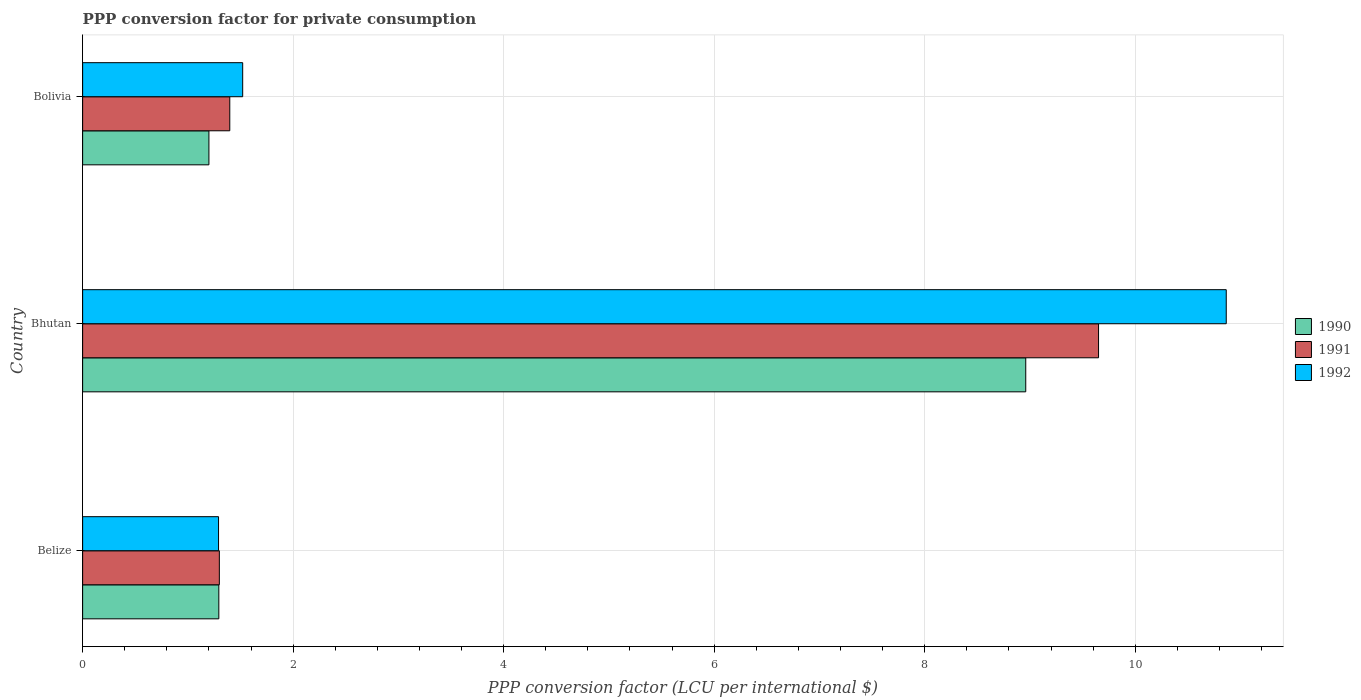How many groups of bars are there?
Your answer should be very brief. 3. Are the number of bars per tick equal to the number of legend labels?
Keep it short and to the point. Yes. What is the label of the 2nd group of bars from the top?
Ensure brevity in your answer.  Bhutan. What is the PPP conversion factor for private consumption in 1992 in Bolivia?
Your answer should be compact. 1.52. Across all countries, what is the maximum PPP conversion factor for private consumption in 1992?
Your answer should be compact. 10.86. Across all countries, what is the minimum PPP conversion factor for private consumption in 1992?
Your answer should be very brief. 1.29. In which country was the PPP conversion factor for private consumption in 1992 maximum?
Your answer should be compact. Bhutan. What is the total PPP conversion factor for private consumption in 1992 in the graph?
Give a very brief answer. 13.68. What is the difference between the PPP conversion factor for private consumption in 1991 in Bhutan and that in Bolivia?
Provide a succinct answer. 8.25. What is the difference between the PPP conversion factor for private consumption in 1992 in Bolivia and the PPP conversion factor for private consumption in 1990 in Belize?
Provide a short and direct response. 0.23. What is the average PPP conversion factor for private consumption in 1990 per country?
Give a very brief answer. 3.82. What is the difference between the PPP conversion factor for private consumption in 1992 and PPP conversion factor for private consumption in 1991 in Bhutan?
Ensure brevity in your answer.  1.21. What is the ratio of the PPP conversion factor for private consumption in 1990 in Bhutan to that in Bolivia?
Offer a very short reply. 7.47. Is the difference between the PPP conversion factor for private consumption in 1992 in Belize and Bhutan greater than the difference between the PPP conversion factor for private consumption in 1991 in Belize and Bhutan?
Make the answer very short. No. What is the difference between the highest and the second highest PPP conversion factor for private consumption in 1990?
Keep it short and to the point. 7.67. What is the difference between the highest and the lowest PPP conversion factor for private consumption in 1992?
Your answer should be compact. 9.57. What does the 2nd bar from the bottom in Bolivia represents?
Your response must be concise. 1991. Are all the bars in the graph horizontal?
Provide a short and direct response. Yes. How many countries are there in the graph?
Keep it short and to the point. 3. Does the graph contain grids?
Offer a very short reply. Yes. Where does the legend appear in the graph?
Provide a succinct answer. Center right. How are the legend labels stacked?
Provide a succinct answer. Vertical. What is the title of the graph?
Your response must be concise. PPP conversion factor for private consumption. Does "1978" appear as one of the legend labels in the graph?
Your answer should be very brief. No. What is the label or title of the X-axis?
Provide a short and direct response. PPP conversion factor (LCU per international $). What is the label or title of the Y-axis?
Your answer should be very brief. Country. What is the PPP conversion factor (LCU per international $) in 1990 in Belize?
Give a very brief answer. 1.29. What is the PPP conversion factor (LCU per international $) in 1991 in Belize?
Your answer should be compact. 1.3. What is the PPP conversion factor (LCU per international $) of 1992 in Belize?
Offer a very short reply. 1.29. What is the PPP conversion factor (LCU per international $) in 1990 in Bhutan?
Ensure brevity in your answer.  8.96. What is the PPP conversion factor (LCU per international $) of 1991 in Bhutan?
Offer a very short reply. 9.65. What is the PPP conversion factor (LCU per international $) of 1992 in Bhutan?
Ensure brevity in your answer.  10.86. What is the PPP conversion factor (LCU per international $) of 1990 in Bolivia?
Your answer should be very brief. 1.2. What is the PPP conversion factor (LCU per international $) in 1991 in Bolivia?
Offer a very short reply. 1.4. What is the PPP conversion factor (LCU per international $) in 1992 in Bolivia?
Your response must be concise. 1.52. Across all countries, what is the maximum PPP conversion factor (LCU per international $) of 1990?
Provide a succinct answer. 8.96. Across all countries, what is the maximum PPP conversion factor (LCU per international $) of 1991?
Provide a succinct answer. 9.65. Across all countries, what is the maximum PPP conversion factor (LCU per international $) in 1992?
Give a very brief answer. 10.86. Across all countries, what is the minimum PPP conversion factor (LCU per international $) in 1990?
Provide a short and direct response. 1.2. Across all countries, what is the minimum PPP conversion factor (LCU per international $) of 1991?
Ensure brevity in your answer.  1.3. Across all countries, what is the minimum PPP conversion factor (LCU per international $) in 1992?
Give a very brief answer. 1.29. What is the total PPP conversion factor (LCU per international $) of 1990 in the graph?
Make the answer very short. 11.45. What is the total PPP conversion factor (LCU per international $) in 1991 in the graph?
Your answer should be very brief. 12.35. What is the total PPP conversion factor (LCU per international $) in 1992 in the graph?
Your answer should be very brief. 13.68. What is the difference between the PPP conversion factor (LCU per international $) of 1990 in Belize and that in Bhutan?
Ensure brevity in your answer.  -7.67. What is the difference between the PPP conversion factor (LCU per international $) of 1991 in Belize and that in Bhutan?
Your response must be concise. -8.35. What is the difference between the PPP conversion factor (LCU per international $) of 1992 in Belize and that in Bhutan?
Offer a terse response. -9.57. What is the difference between the PPP conversion factor (LCU per international $) in 1990 in Belize and that in Bolivia?
Your answer should be very brief. 0.09. What is the difference between the PPP conversion factor (LCU per international $) of 1991 in Belize and that in Bolivia?
Make the answer very short. -0.1. What is the difference between the PPP conversion factor (LCU per international $) in 1992 in Belize and that in Bolivia?
Make the answer very short. -0.23. What is the difference between the PPP conversion factor (LCU per international $) of 1990 in Bhutan and that in Bolivia?
Give a very brief answer. 7.76. What is the difference between the PPP conversion factor (LCU per international $) in 1991 in Bhutan and that in Bolivia?
Ensure brevity in your answer.  8.25. What is the difference between the PPP conversion factor (LCU per international $) in 1992 in Bhutan and that in Bolivia?
Make the answer very short. 9.34. What is the difference between the PPP conversion factor (LCU per international $) of 1990 in Belize and the PPP conversion factor (LCU per international $) of 1991 in Bhutan?
Ensure brevity in your answer.  -8.36. What is the difference between the PPP conversion factor (LCU per international $) in 1990 in Belize and the PPP conversion factor (LCU per international $) in 1992 in Bhutan?
Offer a very short reply. -9.57. What is the difference between the PPP conversion factor (LCU per international $) of 1991 in Belize and the PPP conversion factor (LCU per international $) of 1992 in Bhutan?
Ensure brevity in your answer.  -9.57. What is the difference between the PPP conversion factor (LCU per international $) in 1990 in Belize and the PPP conversion factor (LCU per international $) in 1991 in Bolivia?
Your answer should be very brief. -0.1. What is the difference between the PPP conversion factor (LCU per international $) in 1990 in Belize and the PPP conversion factor (LCU per international $) in 1992 in Bolivia?
Keep it short and to the point. -0.23. What is the difference between the PPP conversion factor (LCU per international $) in 1991 in Belize and the PPP conversion factor (LCU per international $) in 1992 in Bolivia?
Make the answer very short. -0.22. What is the difference between the PPP conversion factor (LCU per international $) of 1990 in Bhutan and the PPP conversion factor (LCU per international $) of 1991 in Bolivia?
Keep it short and to the point. 7.56. What is the difference between the PPP conversion factor (LCU per international $) in 1990 in Bhutan and the PPP conversion factor (LCU per international $) in 1992 in Bolivia?
Make the answer very short. 7.44. What is the difference between the PPP conversion factor (LCU per international $) of 1991 in Bhutan and the PPP conversion factor (LCU per international $) of 1992 in Bolivia?
Provide a succinct answer. 8.13. What is the average PPP conversion factor (LCU per international $) of 1990 per country?
Give a very brief answer. 3.82. What is the average PPP conversion factor (LCU per international $) in 1991 per country?
Make the answer very short. 4.12. What is the average PPP conversion factor (LCU per international $) in 1992 per country?
Offer a very short reply. 4.56. What is the difference between the PPP conversion factor (LCU per international $) in 1990 and PPP conversion factor (LCU per international $) in 1991 in Belize?
Provide a succinct answer. -0. What is the difference between the PPP conversion factor (LCU per international $) of 1990 and PPP conversion factor (LCU per international $) of 1992 in Belize?
Offer a very short reply. 0. What is the difference between the PPP conversion factor (LCU per international $) in 1991 and PPP conversion factor (LCU per international $) in 1992 in Belize?
Make the answer very short. 0.01. What is the difference between the PPP conversion factor (LCU per international $) in 1990 and PPP conversion factor (LCU per international $) in 1991 in Bhutan?
Provide a succinct answer. -0.69. What is the difference between the PPP conversion factor (LCU per international $) of 1990 and PPP conversion factor (LCU per international $) of 1992 in Bhutan?
Offer a terse response. -1.9. What is the difference between the PPP conversion factor (LCU per international $) in 1991 and PPP conversion factor (LCU per international $) in 1992 in Bhutan?
Offer a terse response. -1.21. What is the difference between the PPP conversion factor (LCU per international $) in 1990 and PPP conversion factor (LCU per international $) in 1991 in Bolivia?
Your answer should be very brief. -0.2. What is the difference between the PPP conversion factor (LCU per international $) in 1990 and PPP conversion factor (LCU per international $) in 1992 in Bolivia?
Your response must be concise. -0.32. What is the difference between the PPP conversion factor (LCU per international $) of 1991 and PPP conversion factor (LCU per international $) of 1992 in Bolivia?
Provide a short and direct response. -0.12. What is the ratio of the PPP conversion factor (LCU per international $) in 1990 in Belize to that in Bhutan?
Keep it short and to the point. 0.14. What is the ratio of the PPP conversion factor (LCU per international $) in 1991 in Belize to that in Bhutan?
Provide a succinct answer. 0.13. What is the ratio of the PPP conversion factor (LCU per international $) in 1992 in Belize to that in Bhutan?
Offer a very short reply. 0.12. What is the ratio of the PPP conversion factor (LCU per international $) of 1990 in Belize to that in Bolivia?
Make the answer very short. 1.08. What is the ratio of the PPP conversion factor (LCU per international $) in 1991 in Belize to that in Bolivia?
Offer a very short reply. 0.93. What is the ratio of the PPP conversion factor (LCU per international $) in 1992 in Belize to that in Bolivia?
Offer a very short reply. 0.85. What is the ratio of the PPP conversion factor (LCU per international $) in 1990 in Bhutan to that in Bolivia?
Make the answer very short. 7.47. What is the ratio of the PPP conversion factor (LCU per international $) in 1991 in Bhutan to that in Bolivia?
Your response must be concise. 6.9. What is the ratio of the PPP conversion factor (LCU per international $) in 1992 in Bhutan to that in Bolivia?
Provide a short and direct response. 7.15. What is the difference between the highest and the second highest PPP conversion factor (LCU per international $) of 1990?
Keep it short and to the point. 7.67. What is the difference between the highest and the second highest PPP conversion factor (LCU per international $) of 1991?
Make the answer very short. 8.25. What is the difference between the highest and the second highest PPP conversion factor (LCU per international $) in 1992?
Provide a succinct answer. 9.34. What is the difference between the highest and the lowest PPP conversion factor (LCU per international $) in 1990?
Your response must be concise. 7.76. What is the difference between the highest and the lowest PPP conversion factor (LCU per international $) in 1991?
Give a very brief answer. 8.35. What is the difference between the highest and the lowest PPP conversion factor (LCU per international $) of 1992?
Keep it short and to the point. 9.57. 